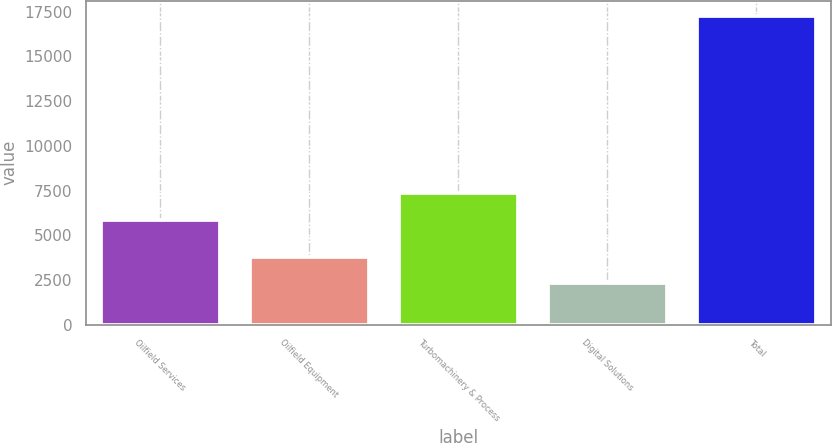Convert chart. <chart><loc_0><loc_0><loc_500><loc_500><bar_chart><fcel>Oilfield Services<fcel>Oilfield Equipment<fcel>Turbomachinery & Process<fcel>Digital Solutions<fcel>Total<nl><fcel>5851<fcel>3804<fcel>7346<fcel>2309<fcel>17259<nl></chart> 